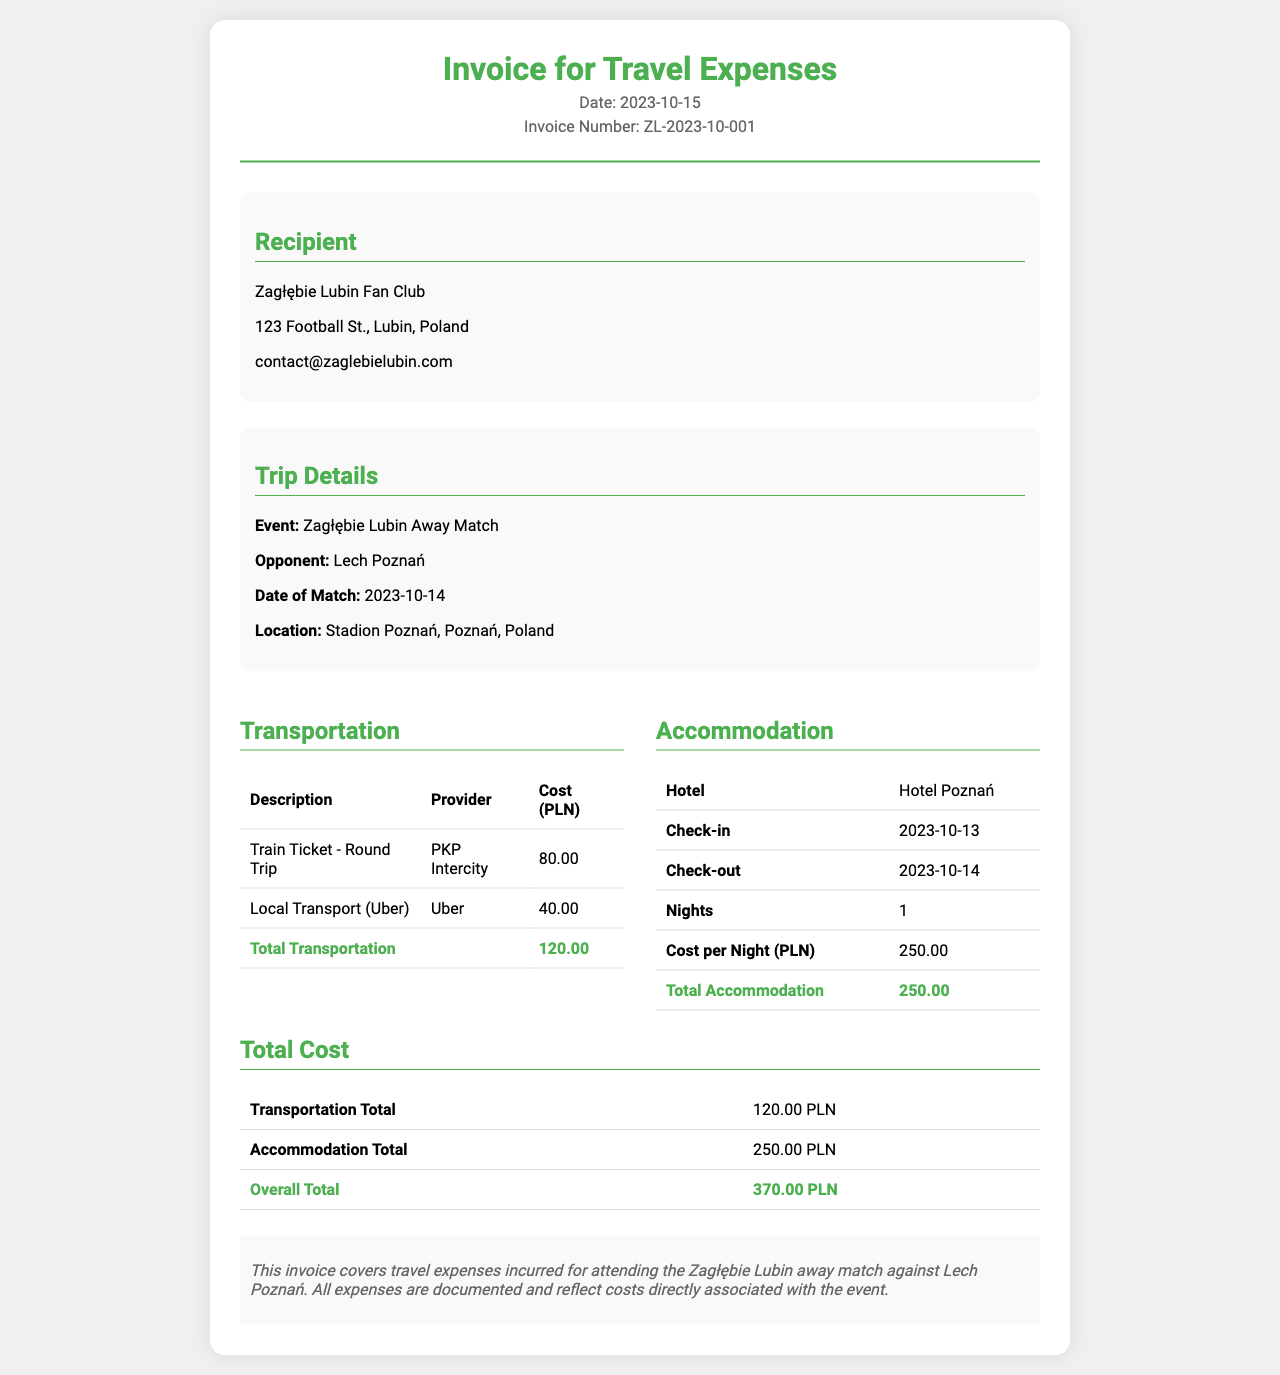What is the invoice date? The invoice date is provided in the header section of the document.
Answer: 2023-10-15 Who is the recipient of the invoice? The recipient is listed in the recipient section of the document.
Answer: Zagłębie Lubin Fan Club What is the total cost of accommodation? The total cost of accommodation is found in the accommodation section of the document.
Answer: 250.00 What is the cost of the train ticket? The train ticket cost is itemized in the transportation table of the document.
Answer: 80.00 What was the date of the match? The date of the match is mentioned in the trip details section of the document.
Answer: 2023-10-14 What is the overall total cost? The overall total cost is calculated at the end of the cost breakdown section of the document.
Answer: 370.00 Which hotel was used for accommodation? The hotel name is provided in the accommodation section of the document.
Answer: Hotel Poznań What type of local transport was used? The type of local transport is detailed in the transportation table of the document.
Answer: Uber How many nights did the stay last? The duration of the stay is mentioned in the accommodation section of the document.
Answer: 1 